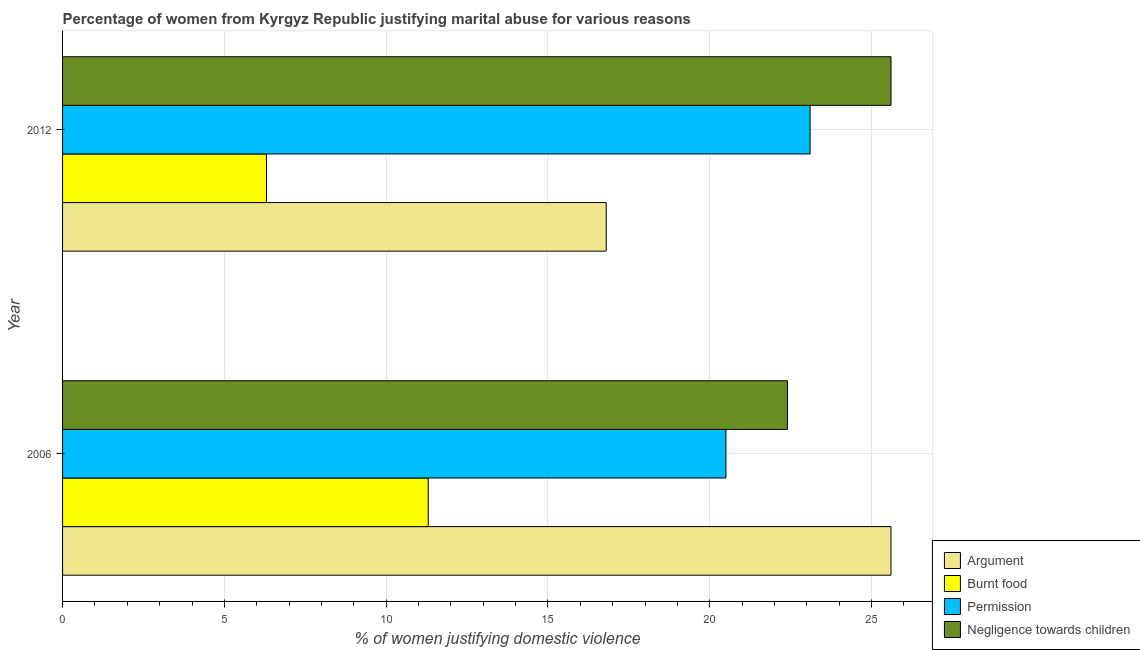How many groups of bars are there?
Provide a short and direct response. 2. Are the number of bars on each tick of the Y-axis equal?
Your answer should be compact. Yes. What is the percentage of women justifying abuse for burning food in 2012?
Make the answer very short. 6.3. Across all years, what is the maximum percentage of women justifying abuse in the case of an argument?
Your answer should be very brief. 25.6. Across all years, what is the minimum percentage of women justifying abuse for showing negligence towards children?
Ensure brevity in your answer.  22.4. In which year was the percentage of women justifying abuse for going without permission maximum?
Your response must be concise. 2012. In which year was the percentage of women justifying abuse for showing negligence towards children minimum?
Ensure brevity in your answer.  2006. What is the total percentage of women justifying abuse for burning food in the graph?
Keep it short and to the point. 17.6. What is the difference between the percentage of women justifying abuse for going without permission in 2006 and that in 2012?
Offer a very short reply. -2.6. What is the average percentage of women justifying abuse for going without permission per year?
Your response must be concise. 21.8. In the year 2012, what is the difference between the percentage of women justifying abuse for burning food and percentage of women justifying abuse for going without permission?
Offer a terse response. -16.8. What is the ratio of the percentage of women justifying abuse for going without permission in 2006 to that in 2012?
Keep it short and to the point. 0.89. In how many years, is the percentage of women justifying abuse for burning food greater than the average percentage of women justifying abuse for burning food taken over all years?
Ensure brevity in your answer.  1. What does the 4th bar from the top in 2012 represents?
Make the answer very short. Argument. What does the 2nd bar from the bottom in 2012 represents?
Offer a very short reply. Burnt food. Are all the bars in the graph horizontal?
Offer a terse response. Yes. What is the difference between two consecutive major ticks on the X-axis?
Offer a very short reply. 5. Are the values on the major ticks of X-axis written in scientific E-notation?
Make the answer very short. No. Does the graph contain any zero values?
Your answer should be compact. No. What is the title of the graph?
Provide a short and direct response. Percentage of women from Kyrgyz Republic justifying marital abuse for various reasons. Does "Arable land" appear as one of the legend labels in the graph?
Offer a terse response. No. What is the label or title of the X-axis?
Give a very brief answer. % of women justifying domestic violence. What is the label or title of the Y-axis?
Offer a very short reply. Year. What is the % of women justifying domestic violence in Argument in 2006?
Offer a terse response. 25.6. What is the % of women justifying domestic violence in Permission in 2006?
Make the answer very short. 20.5. What is the % of women justifying domestic violence in Negligence towards children in 2006?
Give a very brief answer. 22.4. What is the % of women justifying domestic violence in Argument in 2012?
Your response must be concise. 16.8. What is the % of women justifying domestic violence in Burnt food in 2012?
Provide a succinct answer. 6.3. What is the % of women justifying domestic violence in Permission in 2012?
Provide a short and direct response. 23.1. What is the % of women justifying domestic violence in Negligence towards children in 2012?
Offer a terse response. 25.6. Across all years, what is the maximum % of women justifying domestic violence in Argument?
Make the answer very short. 25.6. Across all years, what is the maximum % of women justifying domestic violence of Burnt food?
Offer a terse response. 11.3. Across all years, what is the maximum % of women justifying domestic violence in Permission?
Your response must be concise. 23.1. Across all years, what is the maximum % of women justifying domestic violence in Negligence towards children?
Offer a terse response. 25.6. Across all years, what is the minimum % of women justifying domestic violence of Permission?
Your answer should be compact. 20.5. Across all years, what is the minimum % of women justifying domestic violence of Negligence towards children?
Your answer should be compact. 22.4. What is the total % of women justifying domestic violence of Argument in the graph?
Your answer should be compact. 42.4. What is the total % of women justifying domestic violence in Permission in the graph?
Provide a short and direct response. 43.6. What is the difference between the % of women justifying domestic violence in Negligence towards children in 2006 and that in 2012?
Your response must be concise. -3.2. What is the difference between the % of women justifying domestic violence in Argument in 2006 and the % of women justifying domestic violence in Burnt food in 2012?
Offer a terse response. 19.3. What is the difference between the % of women justifying domestic violence in Burnt food in 2006 and the % of women justifying domestic violence in Permission in 2012?
Your answer should be compact. -11.8. What is the difference between the % of women justifying domestic violence of Burnt food in 2006 and the % of women justifying domestic violence of Negligence towards children in 2012?
Make the answer very short. -14.3. What is the difference between the % of women justifying domestic violence in Permission in 2006 and the % of women justifying domestic violence in Negligence towards children in 2012?
Keep it short and to the point. -5.1. What is the average % of women justifying domestic violence in Argument per year?
Your response must be concise. 21.2. What is the average % of women justifying domestic violence of Burnt food per year?
Your answer should be compact. 8.8. What is the average % of women justifying domestic violence of Permission per year?
Offer a very short reply. 21.8. In the year 2006, what is the difference between the % of women justifying domestic violence in Argument and % of women justifying domestic violence in Burnt food?
Offer a terse response. 14.3. In the year 2006, what is the difference between the % of women justifying domestic violence in Argument and % of women justifying domestic violence in Permission?
Your response must be concise. 5.1. In the year 2006, what is the difference between the % of women justifying domestic violence in Burnt food and % of women justifying domestic violence in Negligence towards children?
Provide a short and direct response. -11.1. In the year 2012, what is the difference between the % of women justifying domestic violence in Argument and % of women justifying domestic violence in Burnt food?
Your answer should be very brief. 10.5. In the year 2012, what is the difference between the % of women justifying domestic violence of Argument and % of women justifying domestic violence of Negligence towards children?
Your response must be concise. -8.8. In the year 2012, what is the difference between the % of women justifying domestic violence of Burnt food and % of women justifying domestic violence of Permission?
Offer a very short reply. -16.8. In the year 2012, what is the difference between the % of women justifying domestic violence of Burnt food and % of women justifying domestic violence of Negligence towards children?
Your answer should be very brief. -19.3. In the year 2012, what is the difference between the % of women justifying domestic violence of Permission and % of women justifying domestic violence of Negligence towards children?
Your answer should be very brief. -2.5. What is the ratio of the % of women justifying domestic violence of Argument in 2006 to that in 2012?
Your answer should be compact. 1.52. What is the ratio of the % of women justifying domestic violence in Burnt food in 2006 to that in 2012?
Make the answer very short. 1.79. What is the ratio of the % of women justifying domestic violence in Permission in 2006 to that in 2012?
Give a very brief answer. 0.89. What is the ratio of the % of women justifying domestic violence of Negligence towards children in 2006 to that in 2012?
Your answer should be compact. 0.88. What is the difference between the highest and the second highest % of women justifying domestic violence in Argument?
Give a very brief answer. 8.8. What is the difference between the highest and the second highest % of women justifying domestic violence in Negligence towards children?
Offer a very short reply. 3.2. What is the difference between the highest and the lowest % of women justifying domestic violence of Burnt food?
Provide a short and direct response. 5. What is the difference between the highest and the lowest % of women justifying domestic violence of Permission?
Your answer should be compact. 2.6. What is the difference between the highest and the lowest % of women justifying domestic violence in Negligence towards children?
Your answer should be very brief. 3.2. 